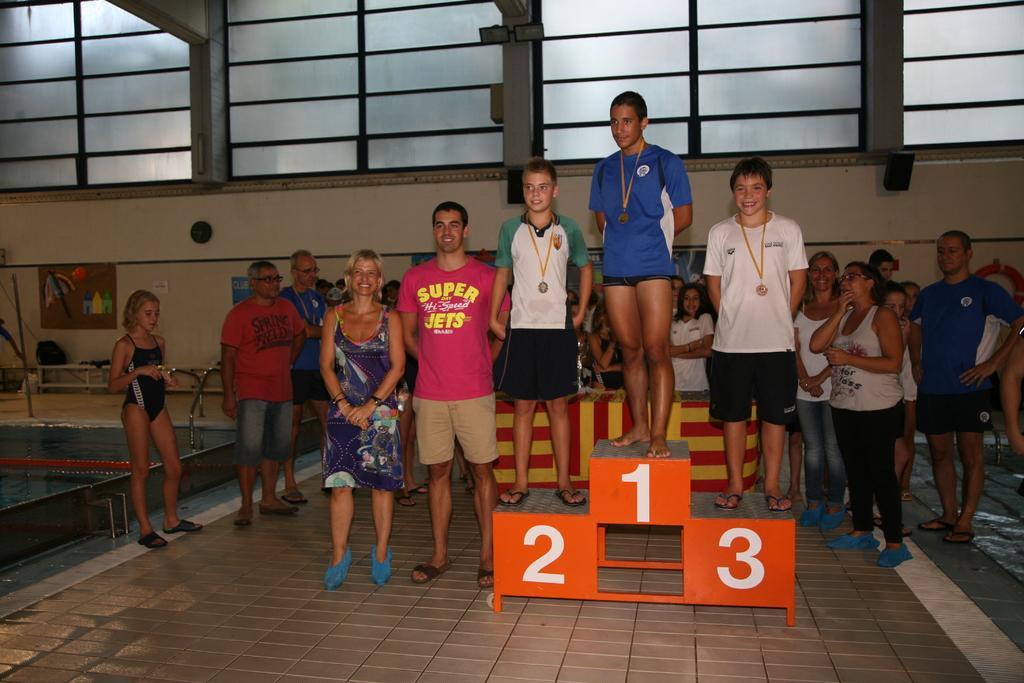Can you describe this image briefly? There are three persons wearing medals are standing on winners podium. Near to them few people are standing. Also there is a table. In the back there is a wall with glass walls. On the wall there are some items pasted. On the left side there is a swimming pool. 